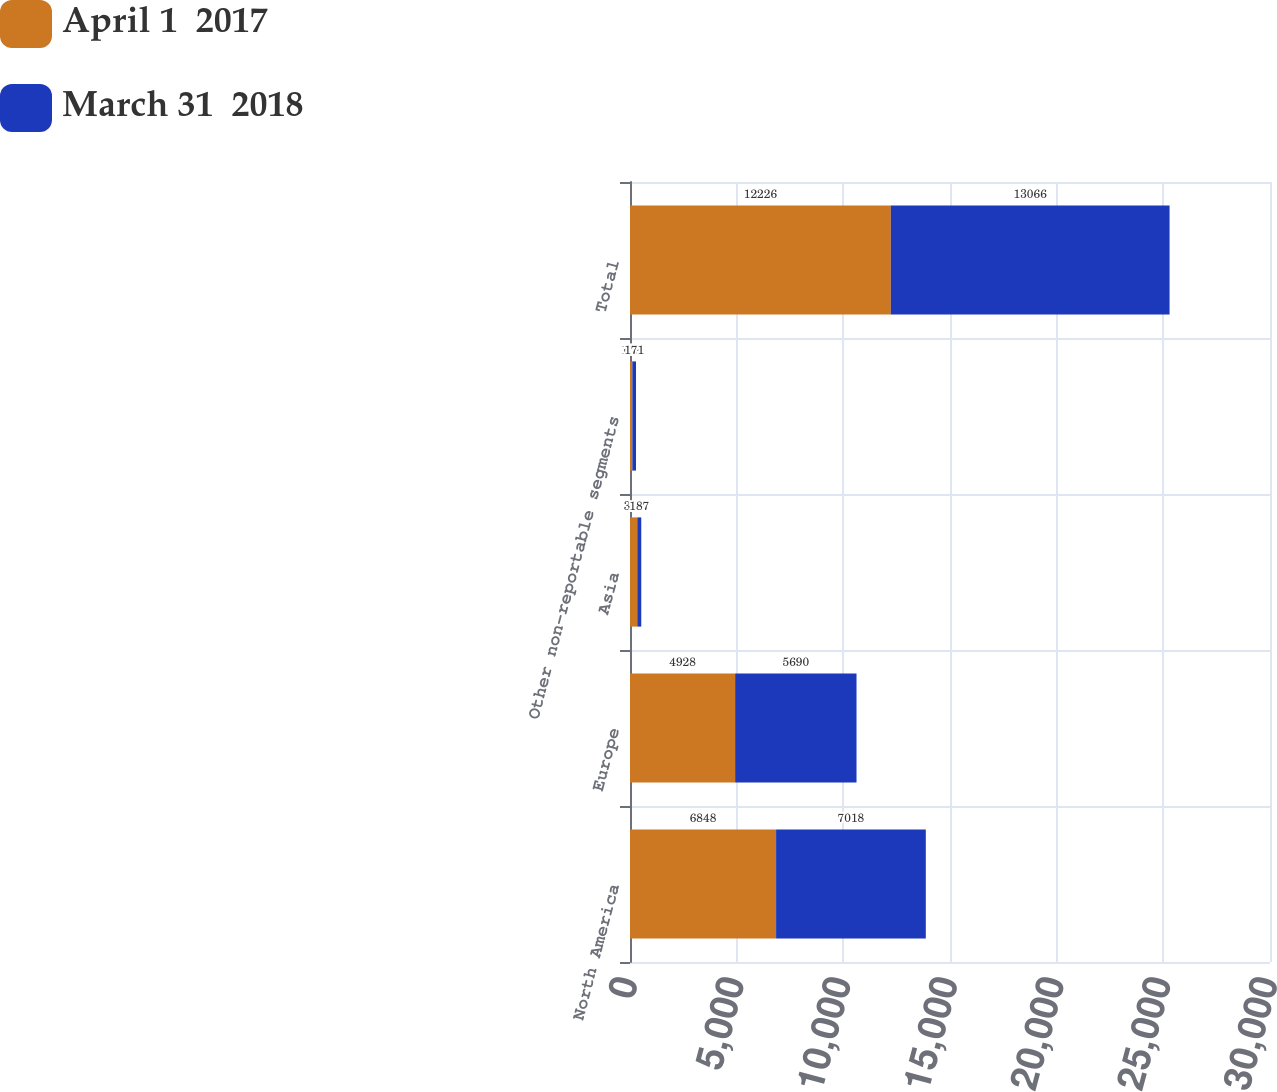Convert chart to OTSL. <chart><loc_0><loc_0><loc_500><loc_500><stacked_bar_chart><ecel><fcel>North America<fcel>Europe<fcel>Asia<fcel>Other non-reportable segments<fcel>Total<nl><fcel>April 1  2017<fcel>6848<fcel>4928<fcel>341<fcel>109<fcel>12226<nl><fcel>March 31  2018<fcel>7018<fcel>5690<fcel>187<fcel>171<fcel>13066<nl></chart> 